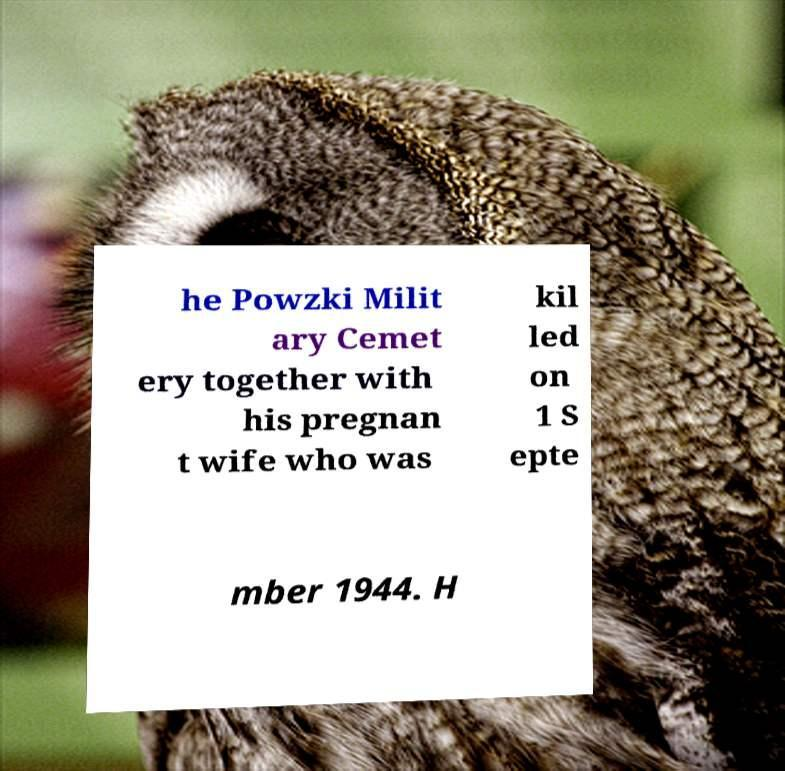Can you read and provide the text displayed in the image?This photo seems to have some interesting text. Can you extract and type it out for me? he Powzki Milit ary Cemet ery together with his pregnan t wife who was kil led on 1 S epte mber 1944. H 